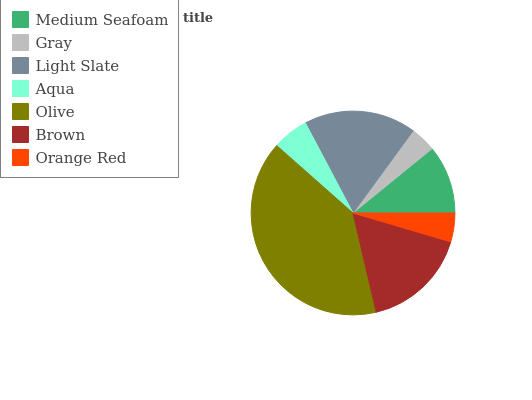Is Gray the minimum?
Answer yes or no. Yes. Is Olive the maximum?
Answer yes or no. Yes. Is Light Slate the minimum?
Answer yes or no. No. Is Light Slate the maximum?
Answer yes or no. No. Is Light Slate greater than Gray?
Answer yes or no. Yes. Is Gray less than Light Slate?
Answer yes or no. Yes. Is Gray greater than Light Slate?
Answer yes or no. No. Is Light Slate less than Gray?
Answer yes or no. No. Is Medium Seafoam the high median?
Answer yes or no. Yes. Is Medium Seafoam the low median?
Answer yes or no. Yes. Is Light Slate the high median?
Answer yes or no. No. Is Brown the low median?
Answer yes or no. No. 